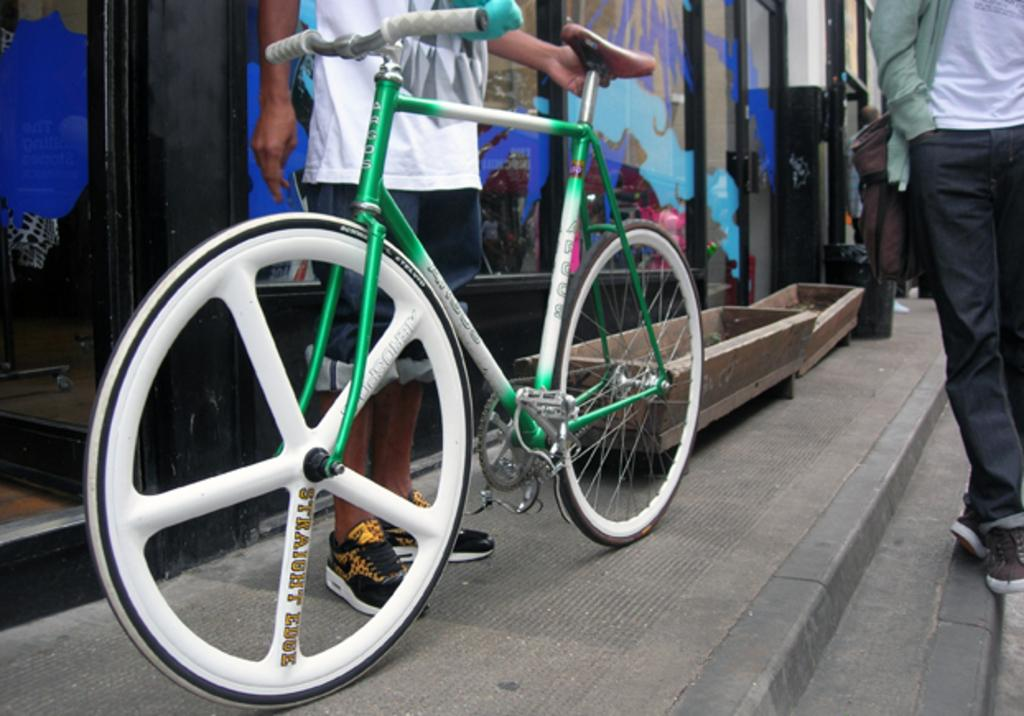What is the main object in the picture? There is a bicycle in the picture. Are there any people present in the image? Yes, there are people standing in the picture. What can be seen in the background of the picture? There is a glass door in the background of the picture. How many pigs are visible in the picture? There are no pigs present in the image. What type of boats can be seen in the background of the picture? There are no boats visible in the picture; it only features a bicycle, people, and a glass door. 